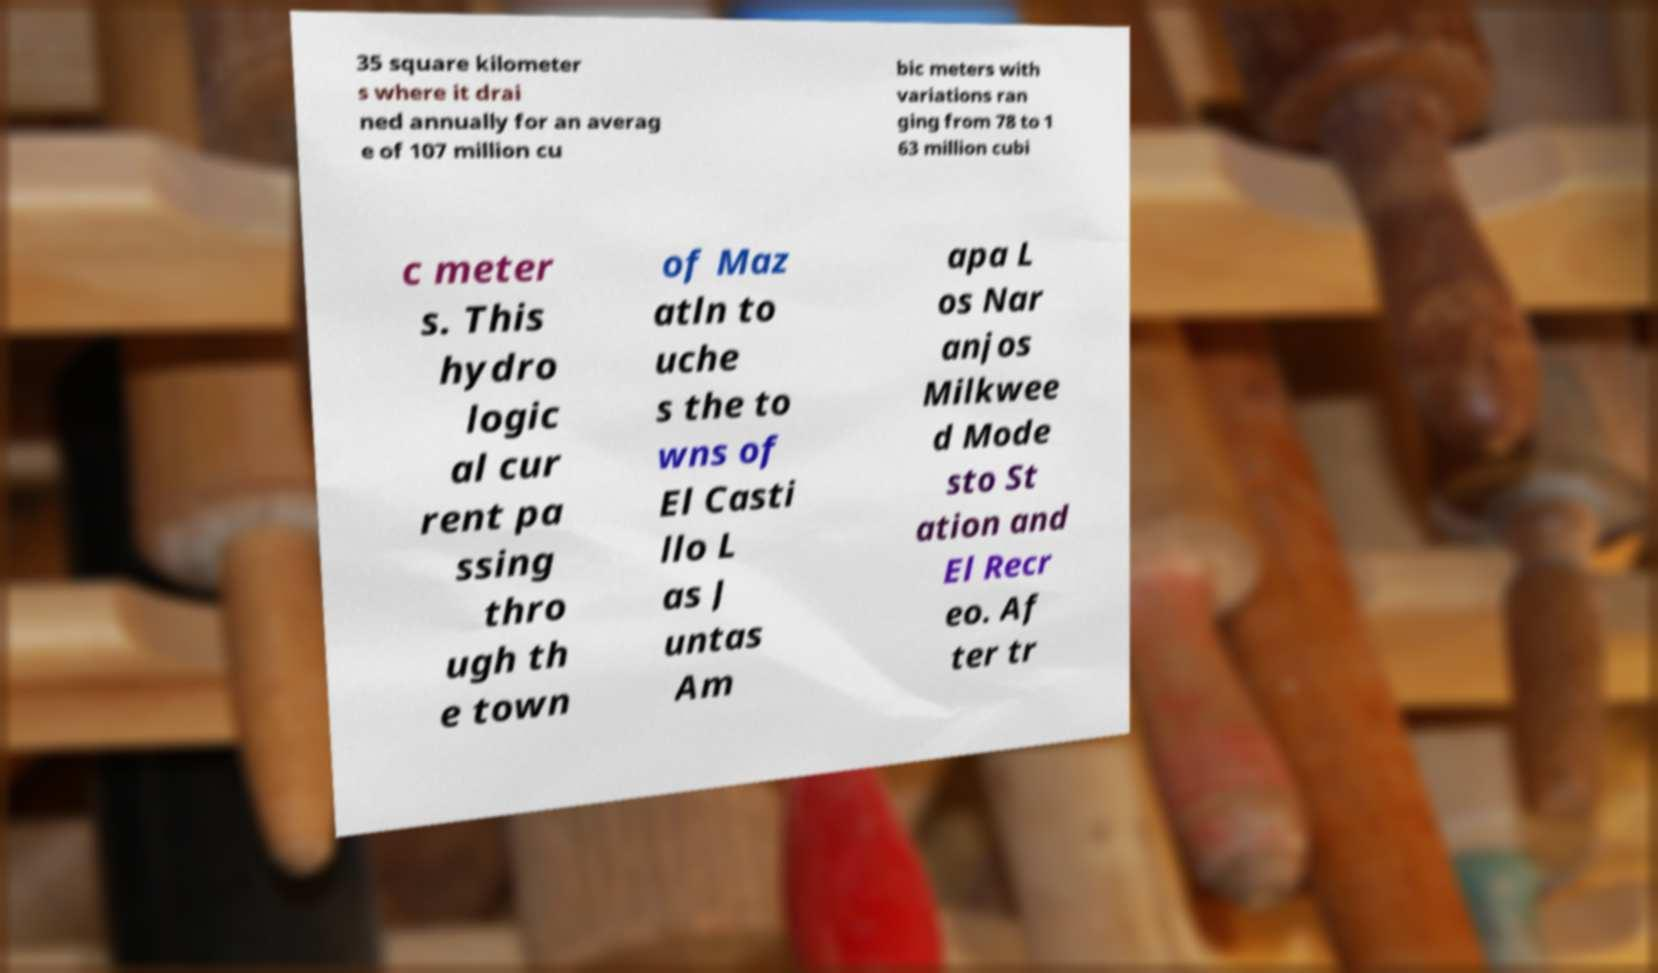I need the written content from this picture converted into text. Can you do that? 35 square kilometer s where it drai ned annually for an averag e of 107 million cu bic meters with variations ran ging from 78 to 1 63 million cubi c meter s. This hydro logic al cur rent pa ssing thro ugh th e town of Maz atln to uche s the to wns of El Casti llo L as J untas Am apa L os Nar anjos Milkwee d Mode sto St ation and El Recr eo. Af ter tr 